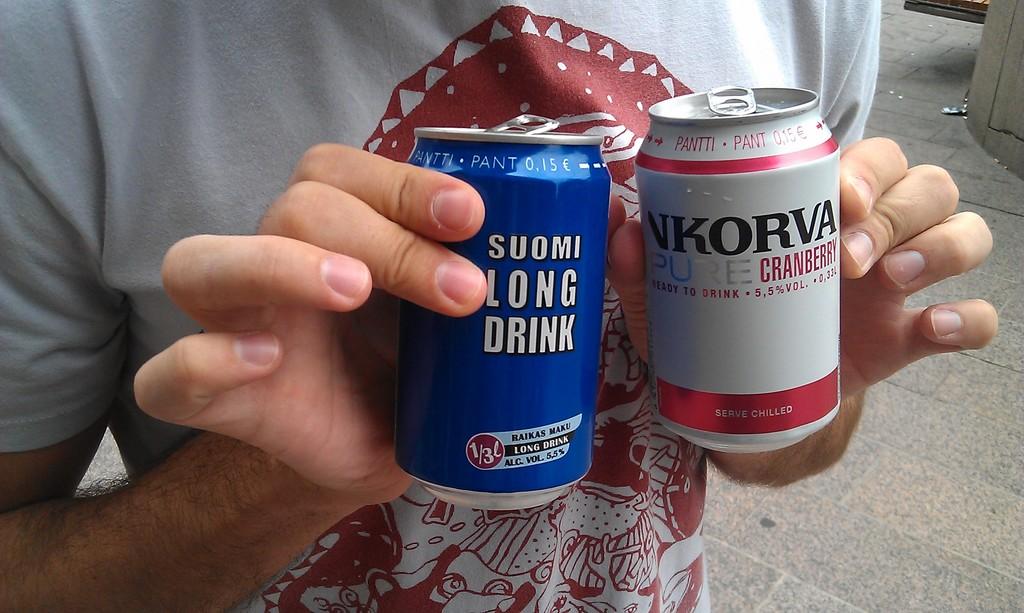Do you have to serve the right one "chilled"?
Provide a short and direct response. Yes. 